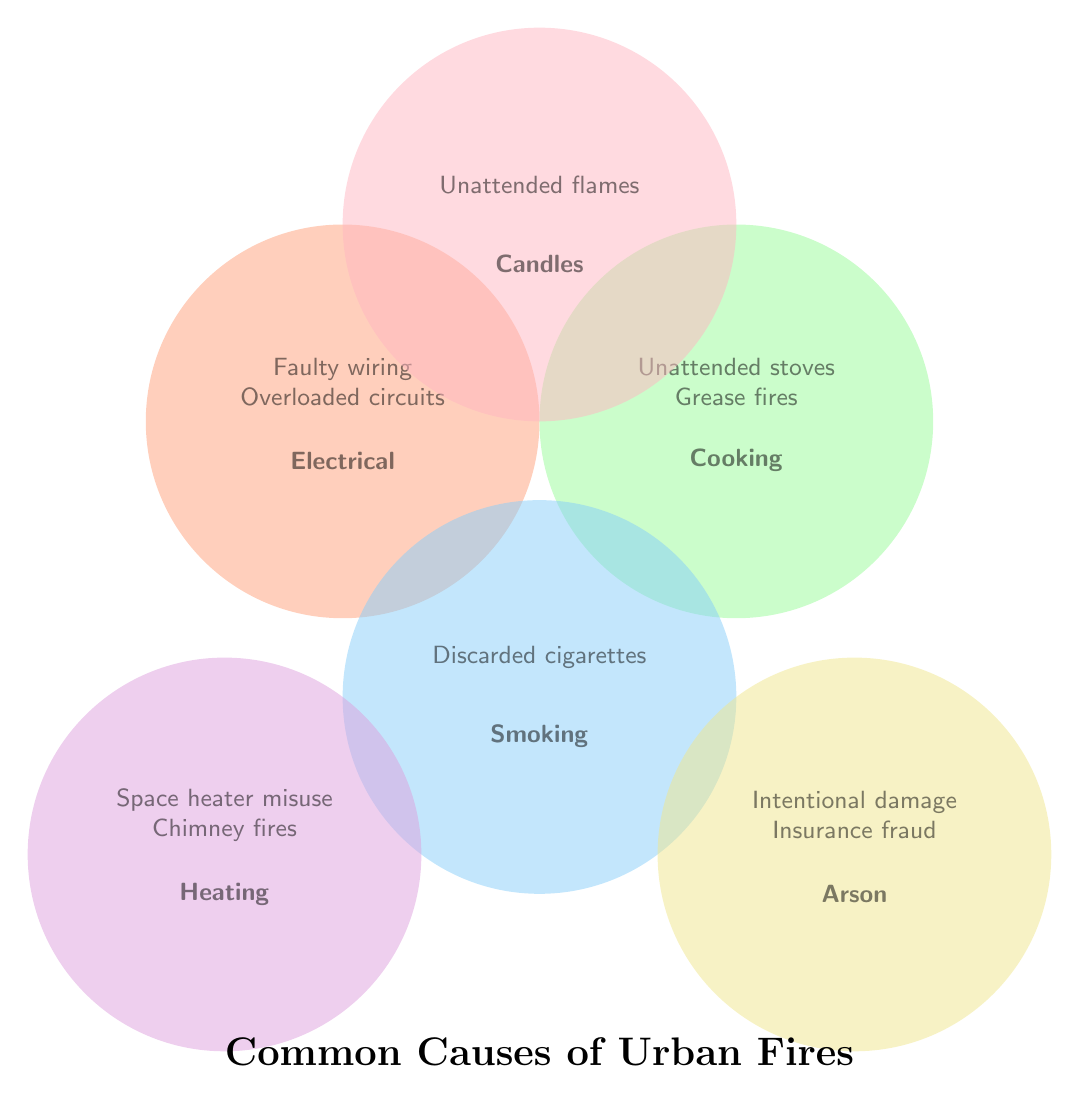What are the causes of fires related to Electrical issues? Identify the circle labeled "Electrical" and observe the listed causes within it.
Answer: Faulty wiring, Overloaded circuits, Malfunctioning appliances Which two categories contain the cause "Unattended open flames"? Inspect the circles and their labels for "Unattended open flames." Notice which categories list this cause.
Answer: Cooking, Candles Which category contains the cause "Space heater misuse"? Identify the circle labeled "Heating" and look inside it for the listed causes.
Answer: Heating How many causes are listed in the Cooking category? Count the causes inside the circle labeled "Cooking."
Answer: 3 Which category overlaps with the Electrical category and also lists “Overloaded circuits”? Locate the circle labeled "Electrical" and find the overlapping category that also has "Overloaded circuits."
Answer: None List all causes related to Arson. Identify the circle labeled "Arson" and list all causes within it.
Answer: Intentional property damage, Insurance fraud How many categories have causes related to Fire Safety? Count the distinct circles representing different categories of fire causes.
Answer: 6 Compare the number of causes in the Smoking category to those in the Candles category. Which has more? Count the causes in both the Smoking and Candles categories and compare the totals.
Answer: Smoking What is a common cause of fires in both the Electrical and Heating categories? Look for causes that appear in both the Electrical and Heating circles.
Answer: None 